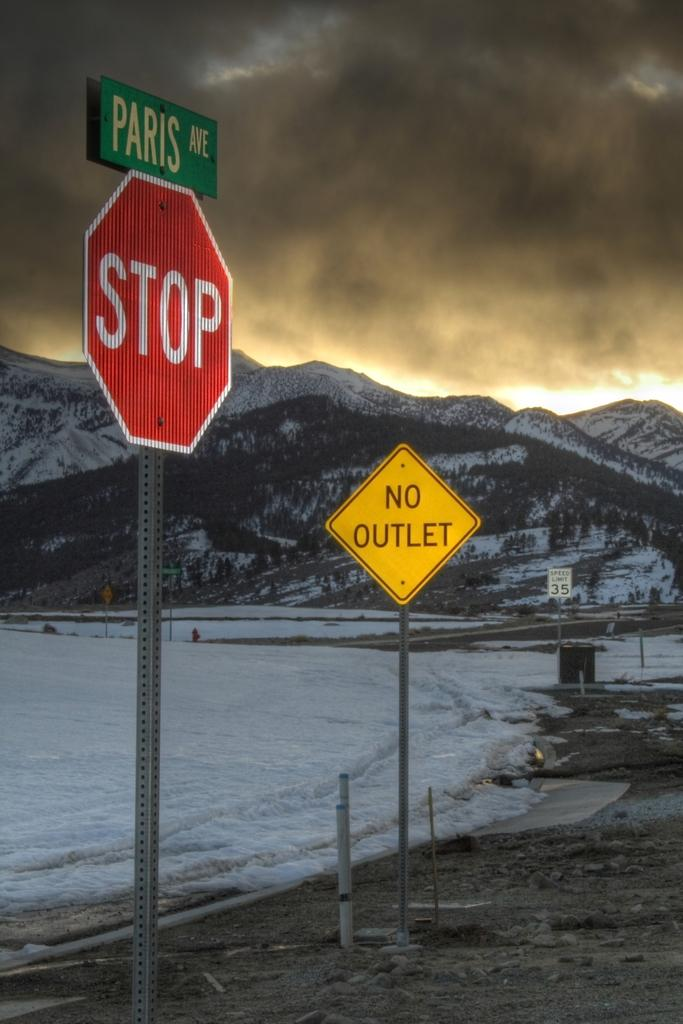<image>
Provide a brief description of the given image. A sign for Paris Avenue is posted above a red stop sign. 